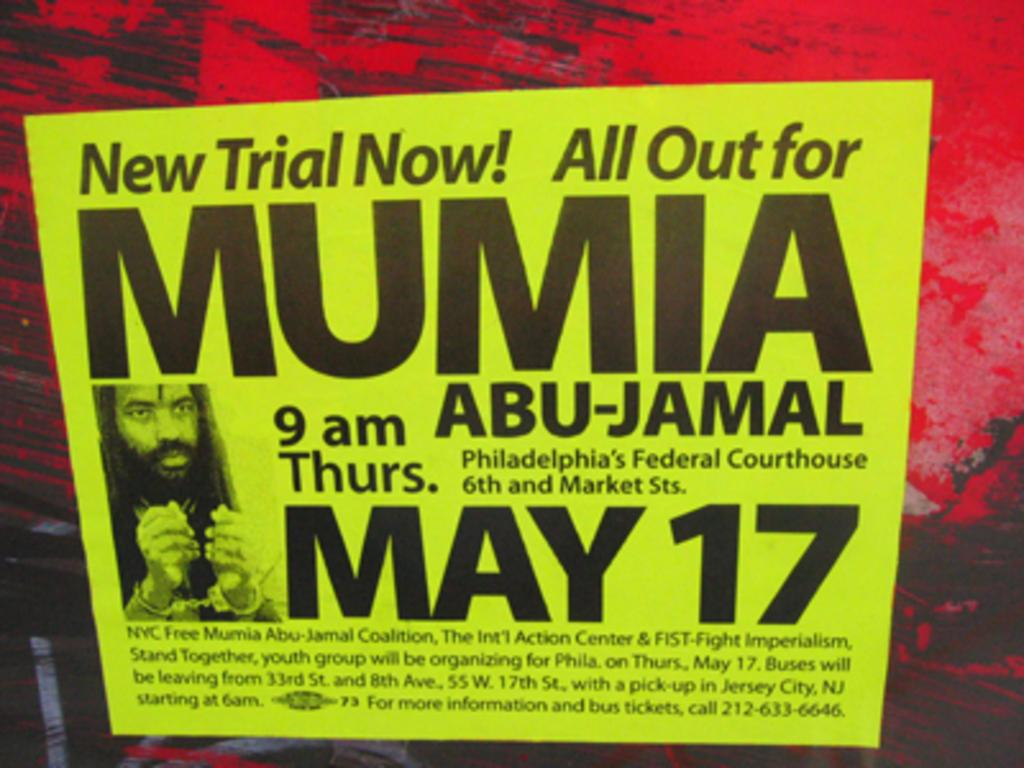<image>
Share a concise interpretation of the image provided. a flyer for the date of may 17  for mumia 